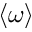<formula> <loc_0><loc_0><loc_500><loc_500>\langle \omega \rangle</formula> 